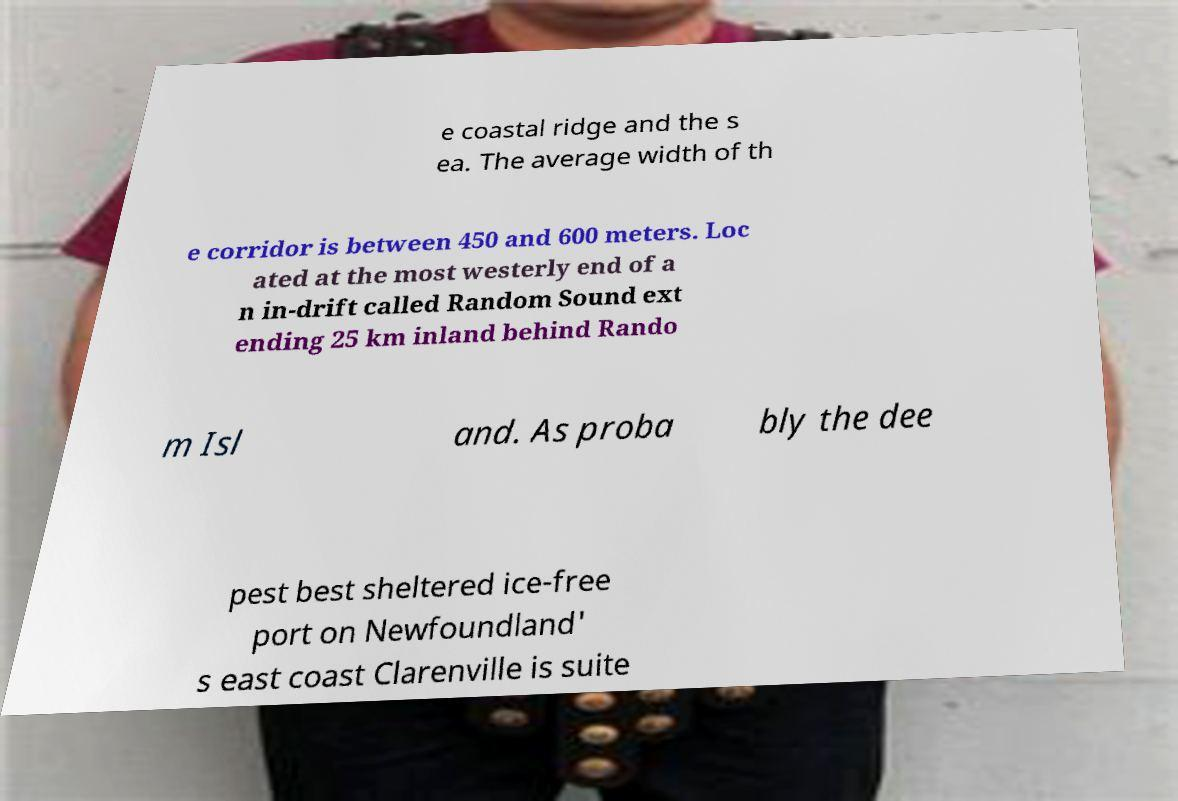There's text embedded in this image that I need extracted. Can you transcribe it verbatim? e coastal ridge and the s ea. The average width of th e corridor is between 450 and 600 meters. Loc ated at the most westerly end of a n in-drift called Random Sound ext ending 25 km inland behind Rando m Isl and. As proba bly the dee pest best sheltered ice-free port on Newfoundland' s east coast Clarenville is suite 